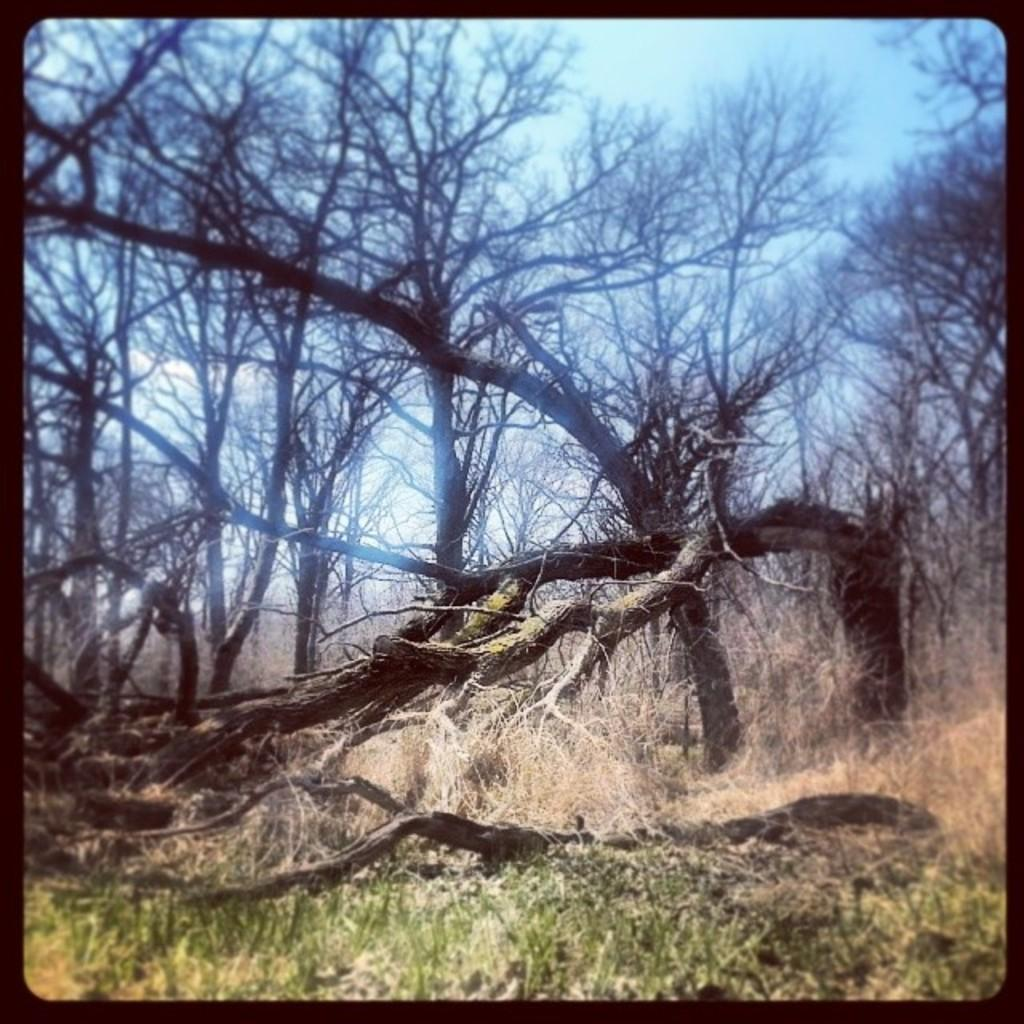What type of vegetation can be seen in the image? There are trees in the image. What is the color of the trees? The trees are brown in color. What other type of vegetation is present in the image? There is grass in the image. What is the color of the grass? The grass is green in color. What can be seen in the background of the image? The sky is visible in the background of the image. How many grapes are hanging from the trees in the image? There are no grapes present in the image; the trees are brown in color. Are there any babies playing with a lock in the image? There are no babies or locks present in the image; it features trees and grass with a visible sky in the background. 